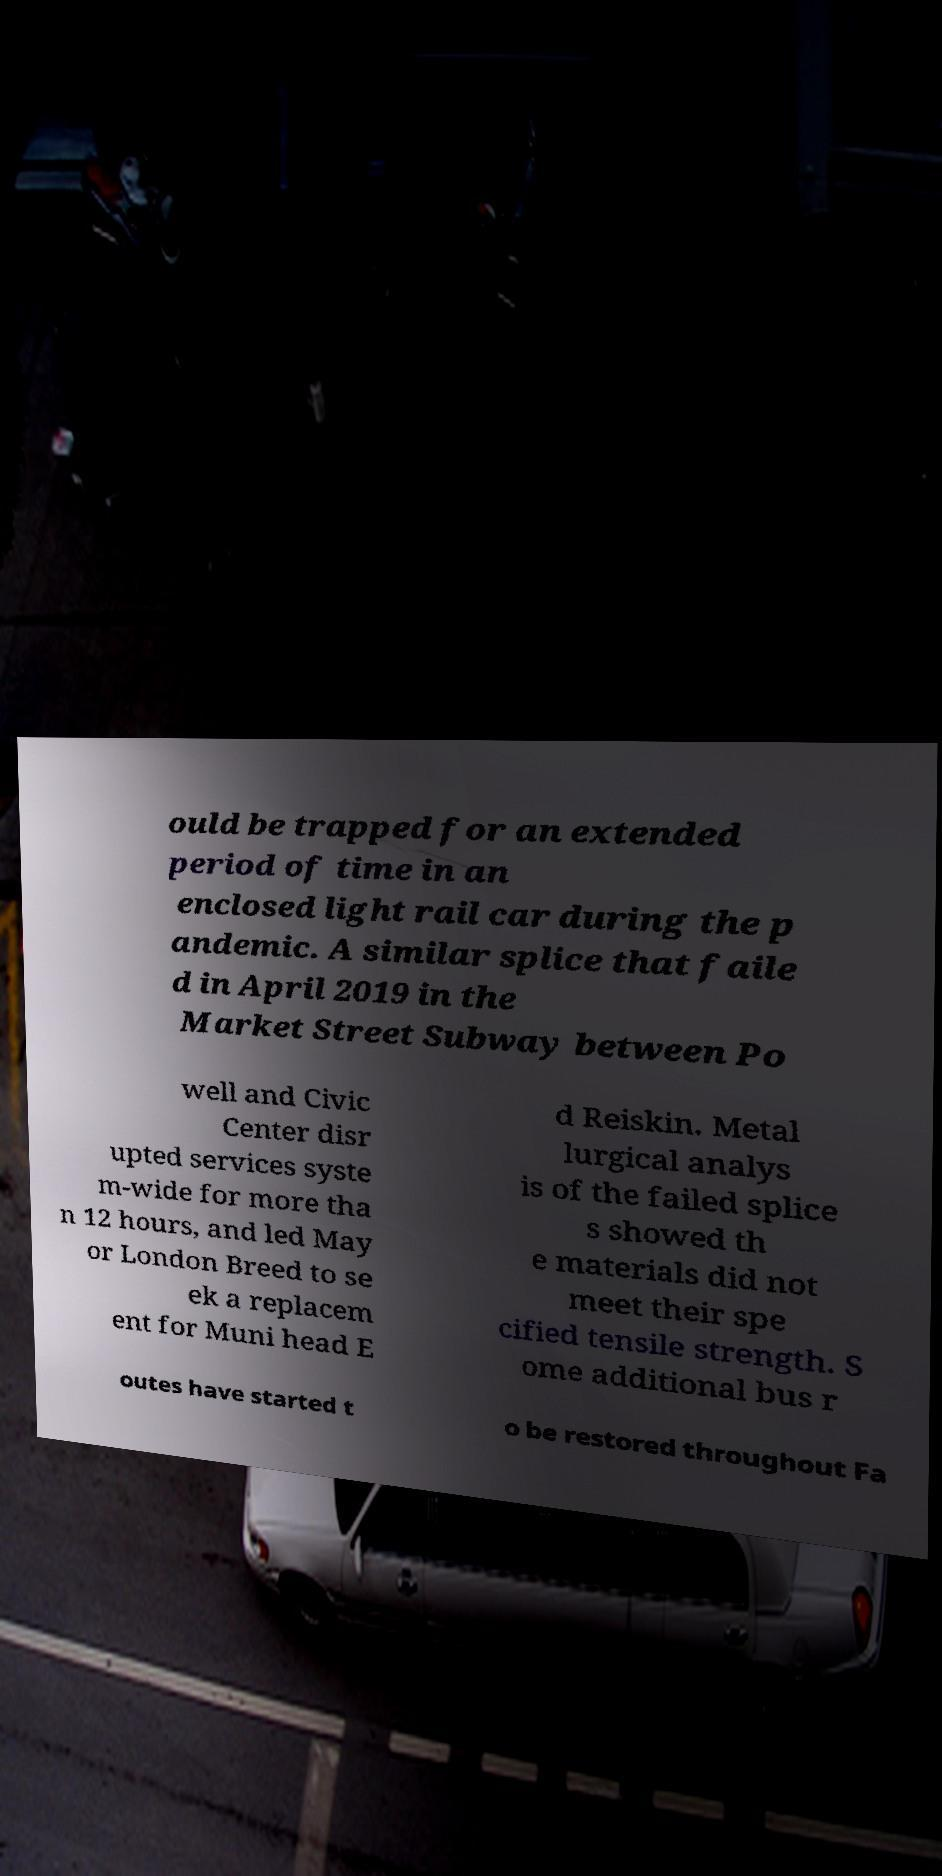Can you accurately transcribe the text from the provided image for me? ould be trapped for an extended period of time in an enclosed light rail car during the p andemic. A similar splice that faile d in April 2019 in the Market Street Subway between Po well and Civic Center disr upted services syste m-wide for more tha n 12 hours, and led May or London Breed to se ek a replacem ent for Muni head E d Reiskin. Metal lurgical analys is of the failed splice s showed th e materials did not meet their spe cified tensile strength. S ome additional bus r outes have started t o be restored throughout Fa 